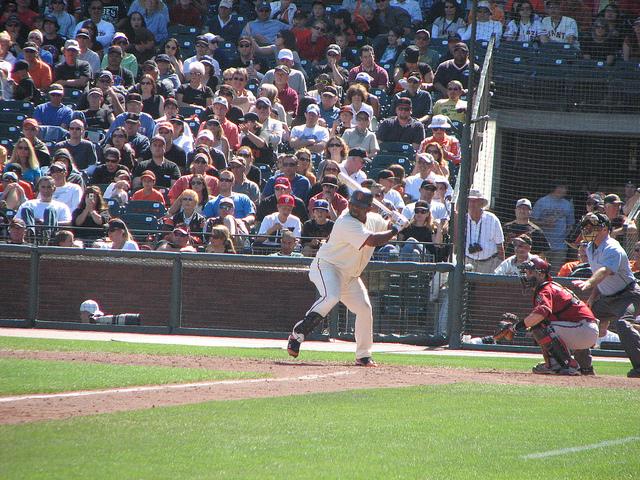This stadium full of spectators?
Answer briefly. Yes. What type of lens is the photographer using?
Keep it brief. Camera. How many people in this shot?
Short answer required. Lot. Why does the player have one leg lifted up?
Quick response, please. Yes. What game are they playing?
Keep it brief. Baseball. 